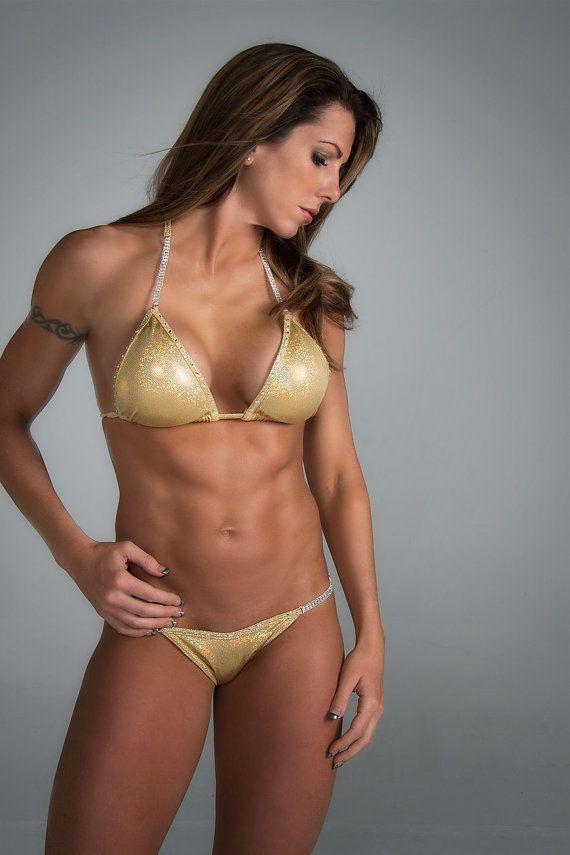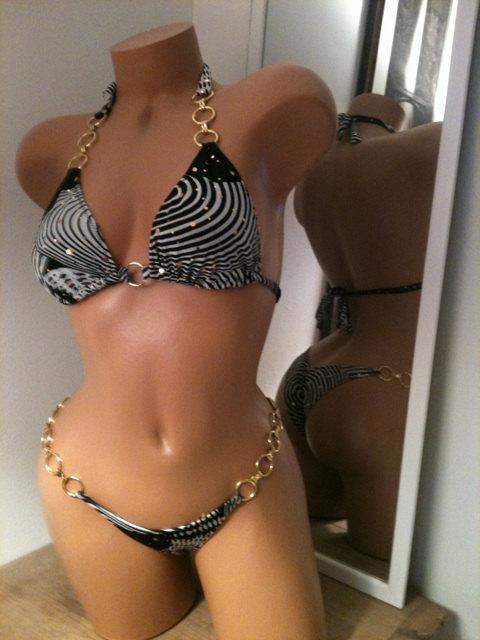The first image is the image on the left, the second image is the image on the right. Considering the images on both sides, is "An image shows a woman wearing a shiny gold bikini and posing with her arm on her hip." valid? Answer yes or no. Yes. The first image is the image on the left, the second image is the image on the right. For the images shown, is this caption "The left and right image contains the same number of bikinis with one being gold." true? Answer yes or no. Yes. 